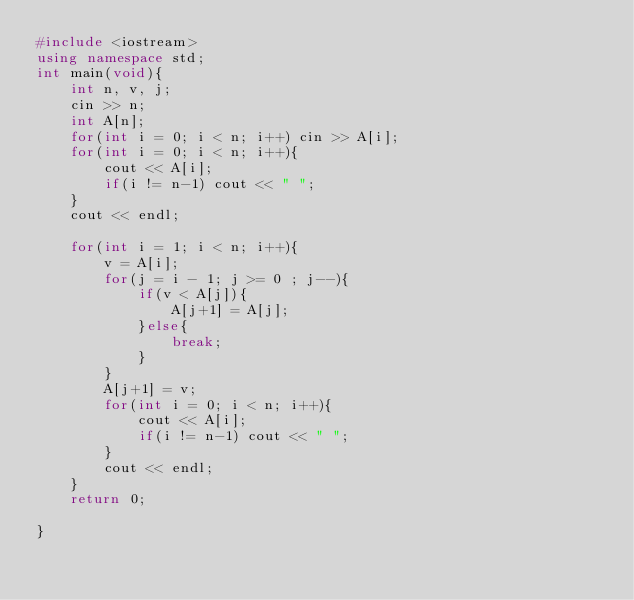Convert code to text. <code><loc_0><loc_0><loc_500><loc_500><_C++_>#include <iostream>
using namespace std;
int main(void){
    int n, v, j;
    cin >> n;
    int A[n];
    for(int i = 0; i < n; i++) cin >> A[i];
    for(int i = 0; i < n; i++){
        cout << A[i];
        if(i != n-1) cout << " ";
    }
    cout << endl;
    
    for(int i = 1; i < n; i++){
        v = A[i];
        for(j = i - 1; j >= 0 ; j--){
            if(v < A[j]){
                A[j+1] = A[j];
            }else{
                break;
            }
        }
        A[j+1] = v;
        for(int i = 0; i < n; i++){
            cout << A[i];
            if(i != n-1) cout << " ";
        }
        cout << endl;
    }
    return 0;
    
}</code> 